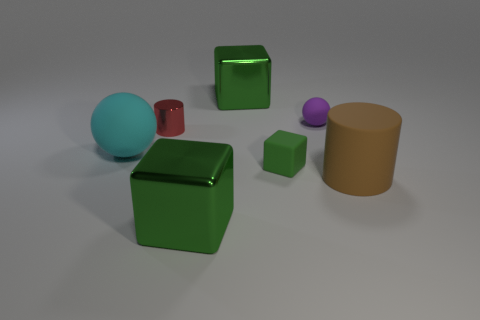What number of blue things are rubber things or matte cylinders?
Keep it short and to the point. 0. What number of other cyan matte spheres are the same size as the cyan ball?
Give a very brief answer. 0. What number of objects are either tiny purple things or tiny matte objects in front of the purple rubber ball?
Provide a succinct answer. 2. There is a green matte thing that is in front of the big cyan matte object; does it have the same size as the ball that is left of the tiny matte cube?
Provide a succinct answer. No. How many tiny green objects have the same shape as the large cyan rubber object?
Provide a short and direct response. 0. There is a tiny green thing that is made of the same material as the large brown object; what is its shape?
Offer a terse response. Cube. There is a large green block that is behind the large metallic block that is in front of the cylinder in front of the small cylinder; what is it made of?
Offer a terse response. Metal. There is a red cylinder; is its size the same as the green shiny cube in front of the large brown matte object?
Offer a terse response. No. There is a cyan object that is the same shape as the tiny purple object; what is its material?
Give a very brief answer. Rubber. What is the size of the cylinder that is left of the cylinder that is to the right of the tiny rubber ball that is left of the big cylinder?
Offer a very short reply. Small. 